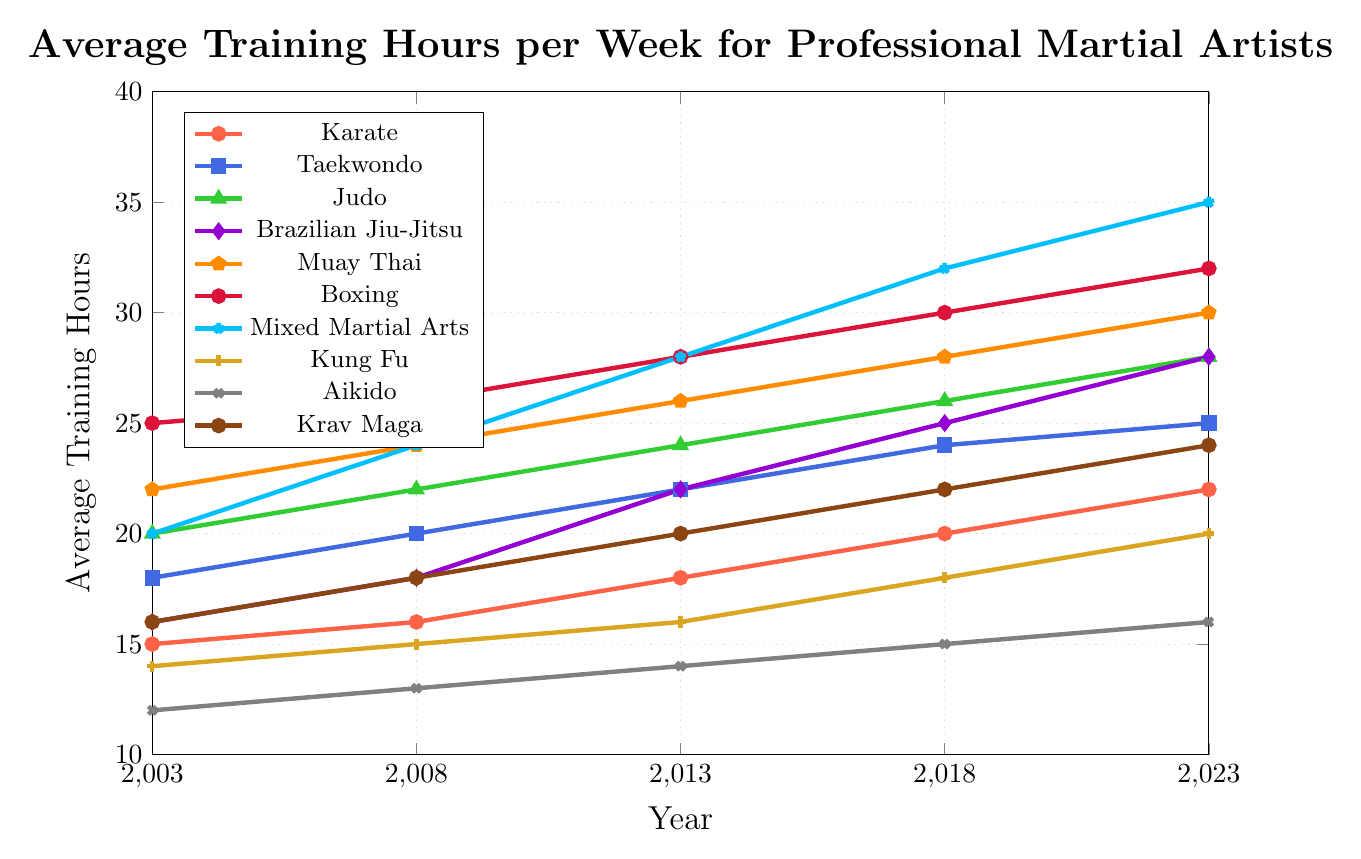What's the average training hours for Taekwondo in 2003 and 2023? Add the training hours for Taekwondo in 2003 and 2023, and then divide by 2. (18 + 25) / 2 = 21.5
Answer: 21.5 Which discipline had the highest increase in training hours from 2003 to 2023? Calculate the difference between the 2023 and 2003 data for each discipline and compare. MMA had the highest increase (35 - 20 = 15).
Answer: Mixed Martial Arts Which discipline had the least training hours in 2003? Refer to the 2003 data for all disciplines and find the smallest value. Aikido had the least training hours in 2003 with 12 hours.
Answer: Aikido By how much did Boxing's training hours increase from 2008 to 2023? Subtract the training hours for Boxing in 2008 from the hours in 2023. 32 - 26 = 6
Answer: 6 What color represents Brazilian Jiu-Jitsu on the line chart? Brazilian Jiu-Jitsu is represented by a purple-colored line on the chart.
Answer: Purple Which discipline had a constant increase in training hours over all the years? Look for a discipline whose training hours increase by the same amount each period. Aikido consistently increased by 1 hour every five years.
Answer: Aikido Between which years did Muay Thai see the smallest increase in training hours? Compare the increases over the pairs of years: 2003-2008, 2008-2013, 2013-2018, and 2018-2023. Muay Thai saw the smallest increase of 2 hours between 2003-2008.
Answer: 2003 to 2008 How does the increase in training hours for Judo compare to Boxing from 2013 to 2023? Calculate the difference for each discipline and compare. Judo: 28 - 24 = 4, Boxing: 32 - 28 = 4. Both saw an increase of 4 hours.
Answer: Equal increase of 4 hours What was the average training hours for all disciplines in 2023? Sum all training hours for 2023 and divide by the number of disciplines. (22+25+28+28+30+32+35+20+16+24) / 10 = 26
Answer: 26 